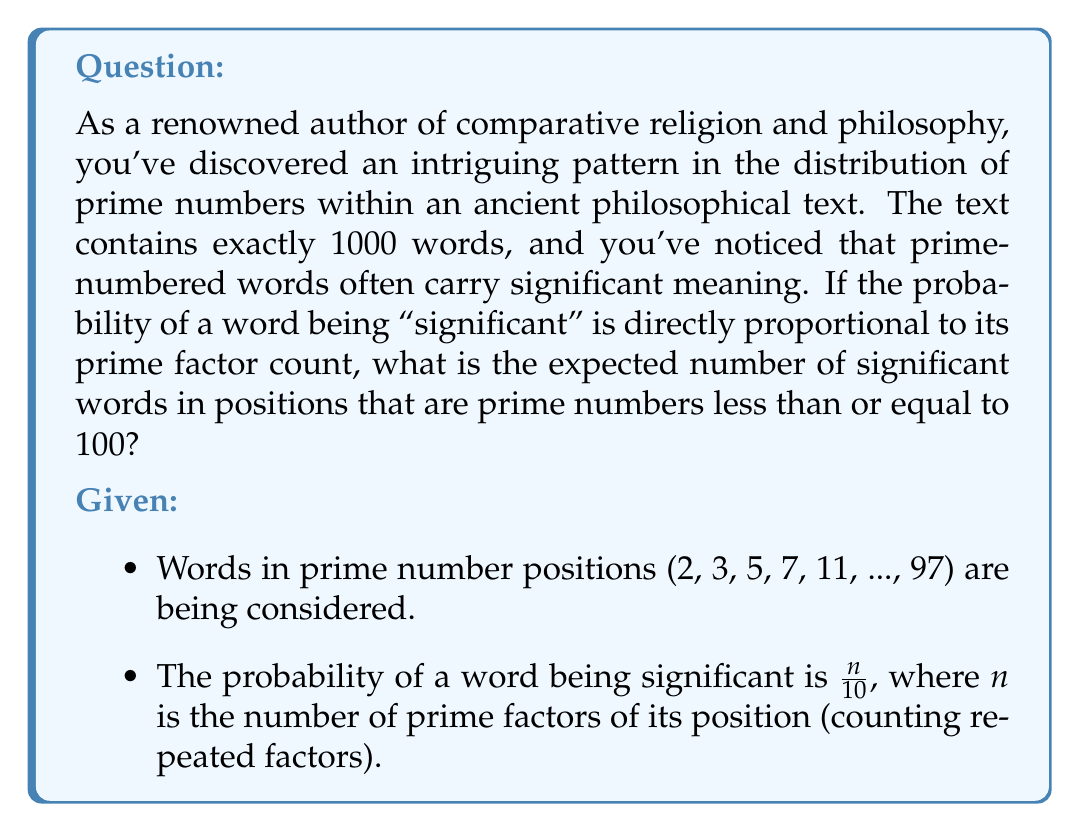Could you help me with this problem? To solve this problem, we need to follow these steps:

1. Identify the prime numbers less than or equal to 100.
2. For each of these primes, determine the number of prime factors.
3. Calculate the probability of each word being significant.
4. Sum these probabilities to get the expected number of significant words.

Step 1: Prime numbers ≤ 100
2, 3, 5, 7, 11, 13, 17, 19, 23, 29, 31, 37, 41, 43, 47, 53, 59, 61, 67, 71, 73, 79, 83, 89, 97

Step 2 & 3: Determine prime factors and calculate probabilities

For each prime p, the probability is $\frac{1}{10}$ because each prime has exactly one prime factor (itself).

Step 4: Sum the probabilities

There are 25 primes in this range, so the expected number of significant words is:

$$\sum_{p \leq 100, p \text{ prime}} \frac{1}{10} = 25 \cdot \frac{1}{10} = \frac{25}{10} = 2.5$$

Therefore, the expected number of significant words in prime positions less than or equal to 100 is 2.5.
Answer: 2.5 